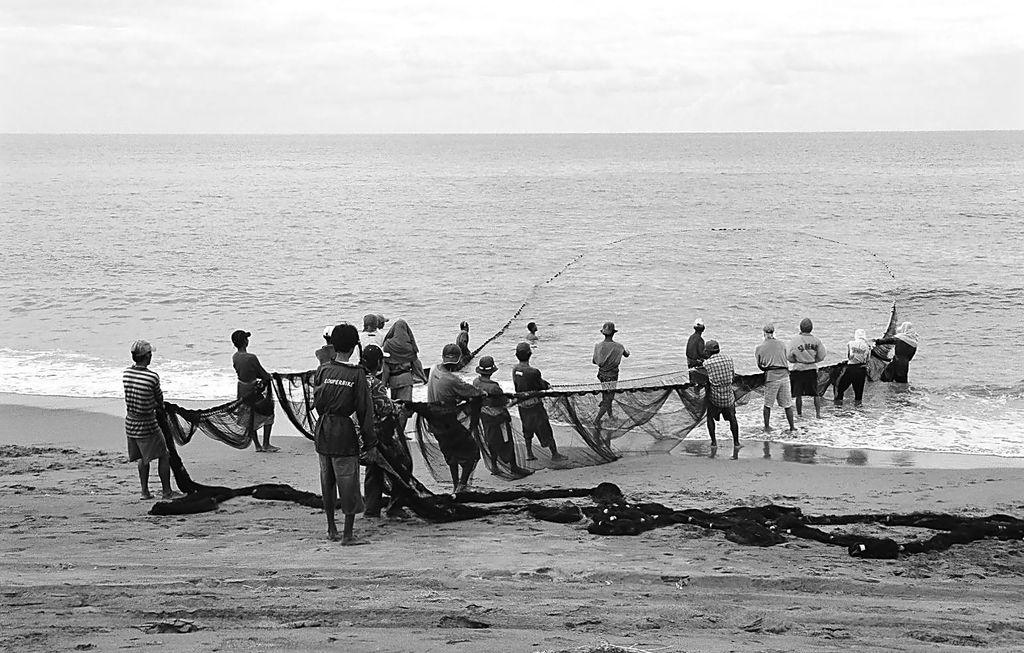How many people are in the group visible in the image? There is a group of people in the image, but the exact number is not specified. What are the people carrying in the image? The people are carrying a net in the image. What is the location of the scene in the image? The scene is near the sea in the image. What is the weather like in the image? The sky is cloudy in the image, suggesting a potentially overcast or rainy day. Can you see any veins in the image? There are no veins visible in the image, as it features a group of people carrying a net near the sea. What type of drum is being played in the image? There is no drum present in the image; it features a group of people carrying a net near the sea. 